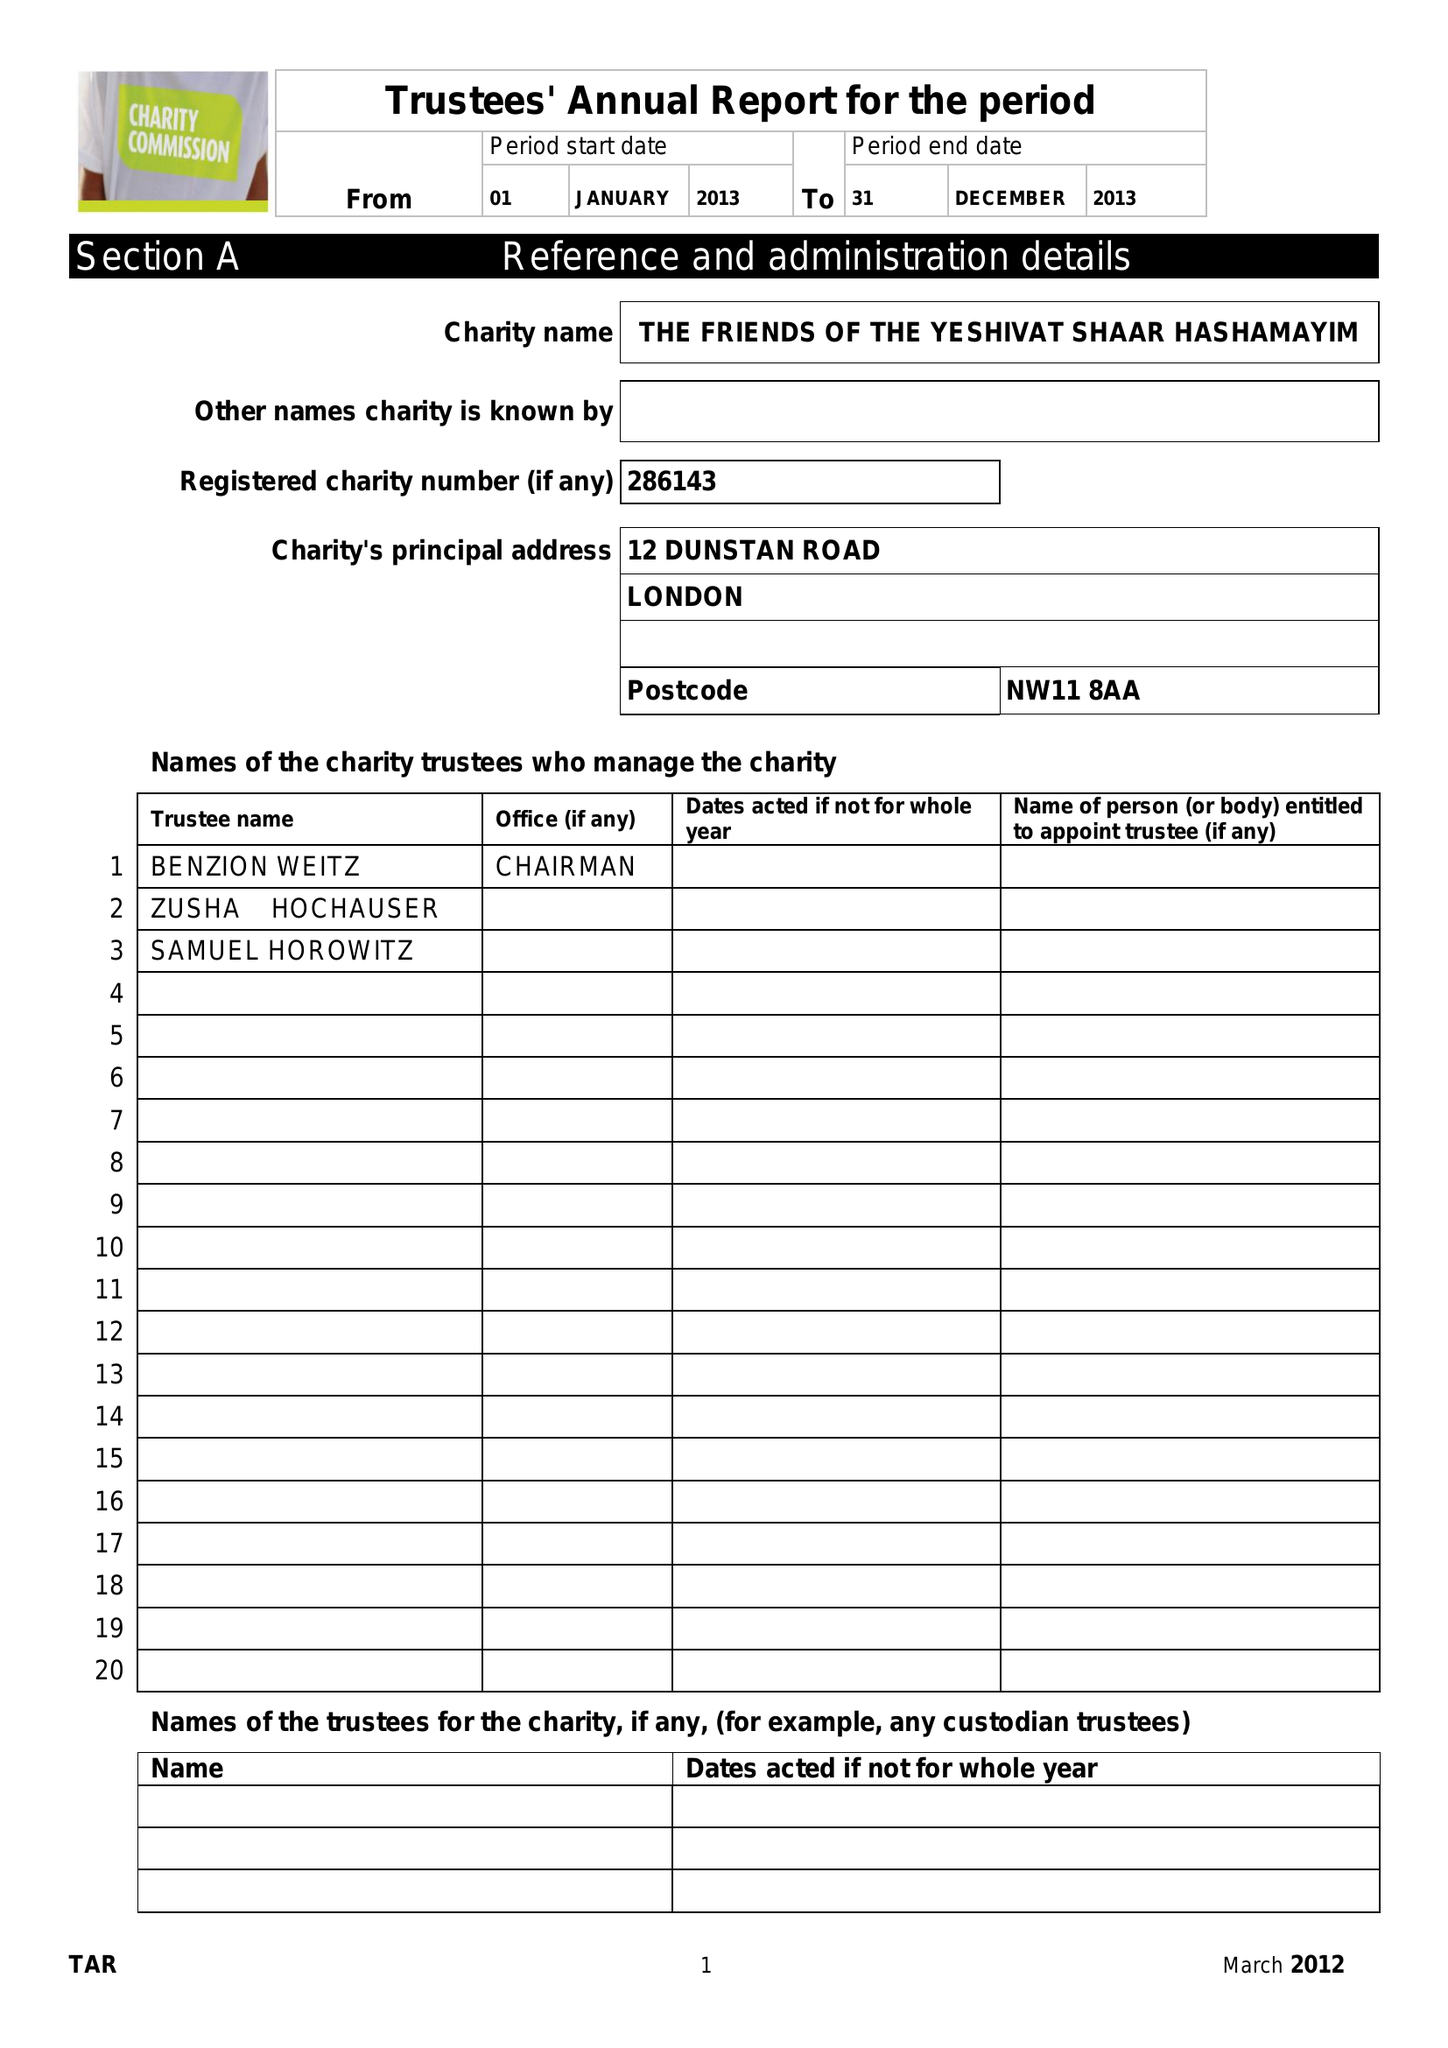What is the value for the charity_number?
Answer the question using a single word or phrase. 286143 